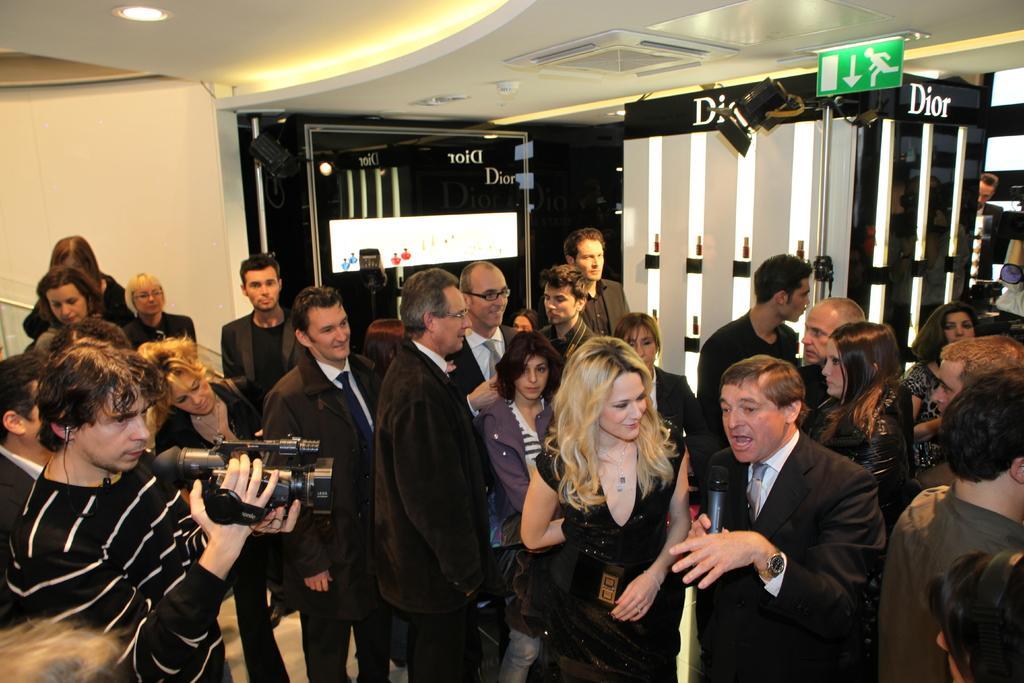Can you describe this image briefly? In this image there are a group of people standing and one person is holding a camera and one person is holding a mike and talking. And in the background there are some boards and some other objects and wall, at the top there is ceiling and some lights. 